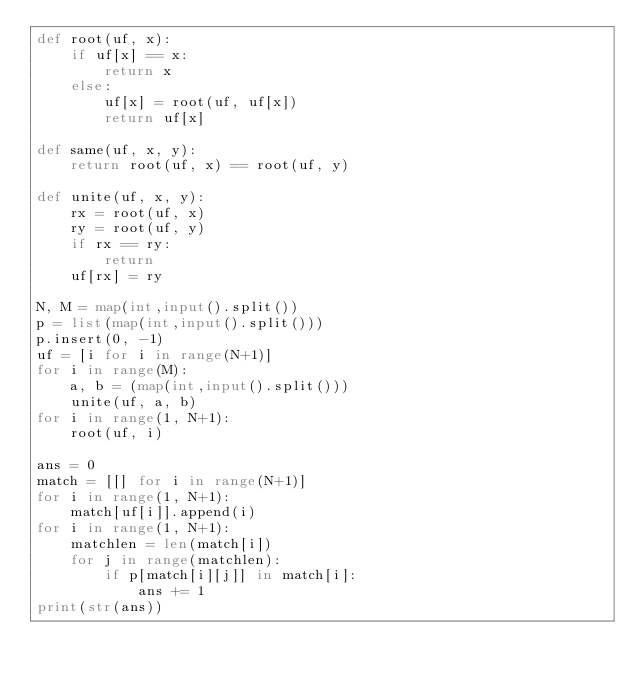<code> <loc_0><loc_0><loc_500><loc_500><_Python_>def root(uf, x):
    if uf[x] == x:
        return x
    else:
        uf[x] = root(uf, uf[x])
        return uf[x]

def same(uf, x, y):
    return root(uf, x) == root(uf, y)

def unite(uf, x, y):
    rx = root(uf, x)
    ry = root(uf, y)
    if rx == ry:
        return
    uf[rx] = ry

N, M = map(int,input().split())
p = list(map(int,input().split()))
p.insert(0, -1)
uf = [i for i in range(N+1)]
for i in range(M):
    a, b = (map(int,input().split()))
    unite(uf, a, b)
for i in range(1, N+1):
    root(uf, i)

ans = 0
match = [[] for i in range(N+1)]
for i in range(1, N+1):
    match[uf[i]].append(i)
for i in range(1, N+1):
    matchlen = len(match[i])
    for j in range(matchlen):
        if p[match[i][j]] in match[i]:
            ans += 1
print(str(ans))</code> 